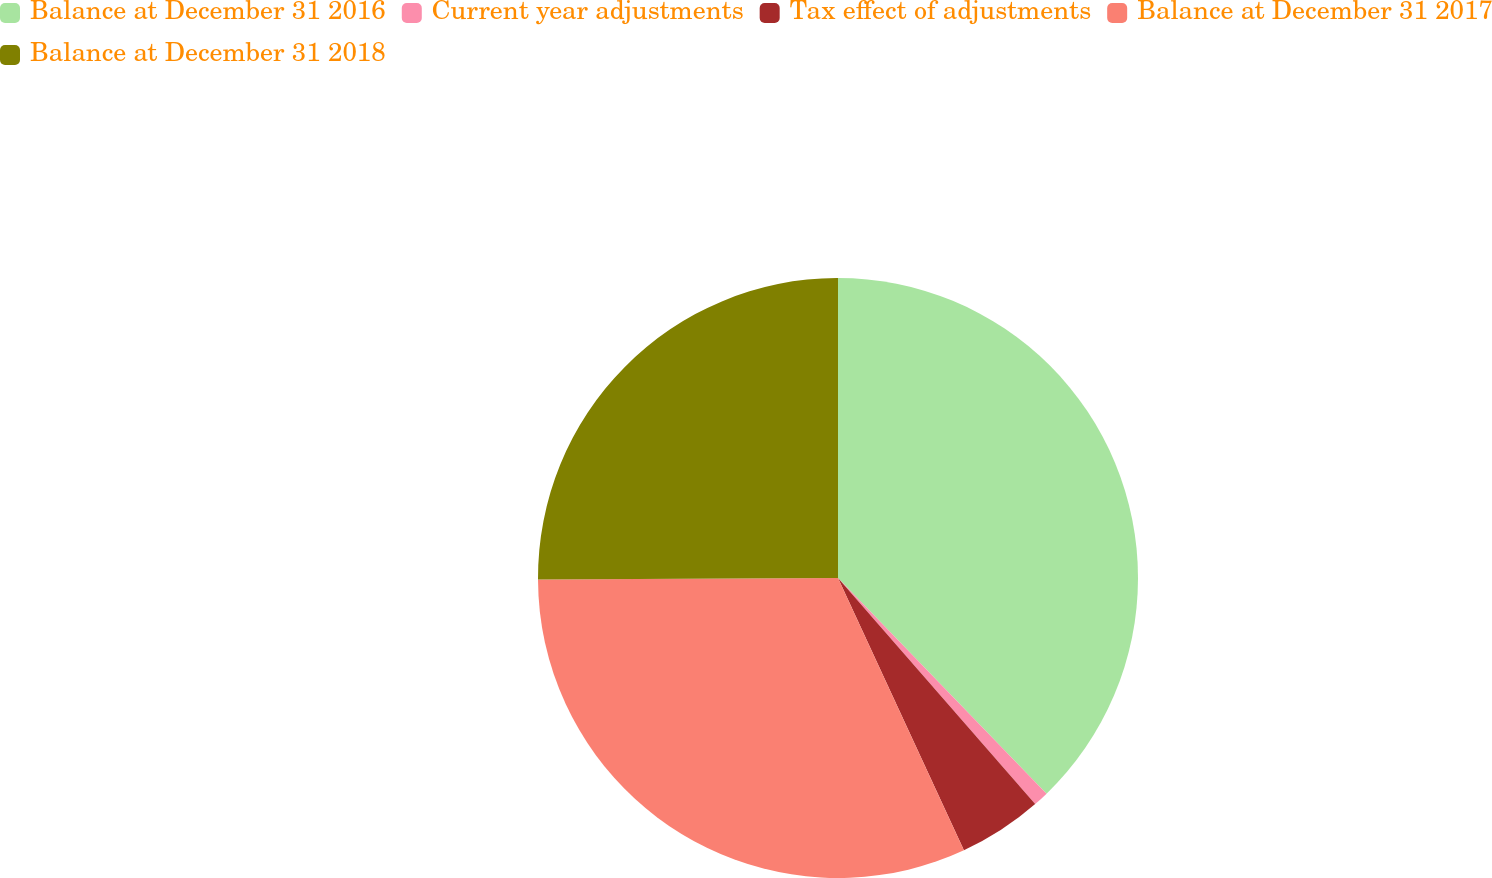<chart> <loc_0><loc_0><loc_500><loc_500><pie_chart><fcel>Balance at December 31 2016<fcel>Current year adjustments<fcel>Tax effect of adjustments<fcel>Balance at December 31 2017<fcel>Balance at December 31 2018<nl><fcel>37.77%<fcel>0.82%<fcel>4.52%<fcel>31.82%<fcel>25.08%<nl></chart> 